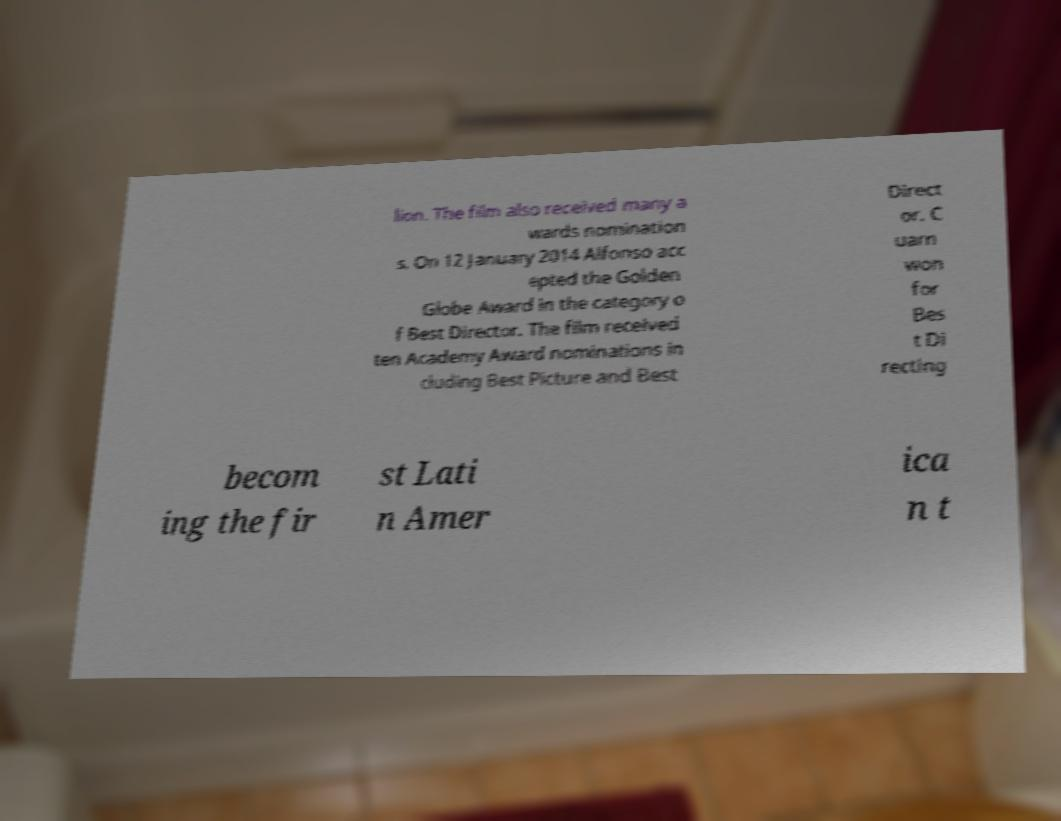There's text embedded in this image that I need extracted. Can you transcribe it verbatim? lion. The film also received many a wards nomination s. On 12 January 2014 Alfonso acc epted the Golden Globe Award in the category o f Best Director. The film received ten Academy Award nominations in cluding Best Picture and Best Direct or. C uarn won for Bes t Di recting becom ing the fir st Lati n Amer ica n t 